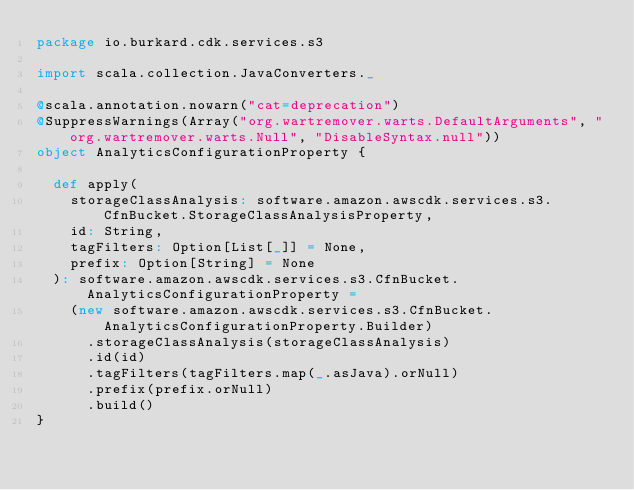Convert code to text. <code><loc_0><loc_0><loc_500><loc_500><_Scala_>package io.burkard.cdk.services.s3

import scala.collection.JavaConverters._

@scala.annotation.nowarn("cat=deprecation")
@SuppressWarnings(Array("org.wartremover.warts.DefaultArguments", "org.wartremover.warts.Null", "DisableSyntax.null"))
object AnalyticsConfigurationProperty {

  def apply(
    storageClassAnalysis: software.amazon.awscdk.services.s3.CfnBucket.StorageClassAnalysisProperty,
    id: String,
    tagFilters: Option[List[_]] = None,
    prefix: Option[String] = None
  ): software.amazon.awscdk.services.s3.CfnBucket.AnalyticsConfigurationProperty =
    (new software.amazon.awscdk.services.s3.CfnBucket.AnalyticsConfigurationProperty.Builder)
      .storageClassAnalysis(storageClassAnalysis)
      .id(id)
      .tagFilters(tagFilters.map(_.asJava).orNull)
      .prefix(prefix.orNull)
      .build()
}
</code> 